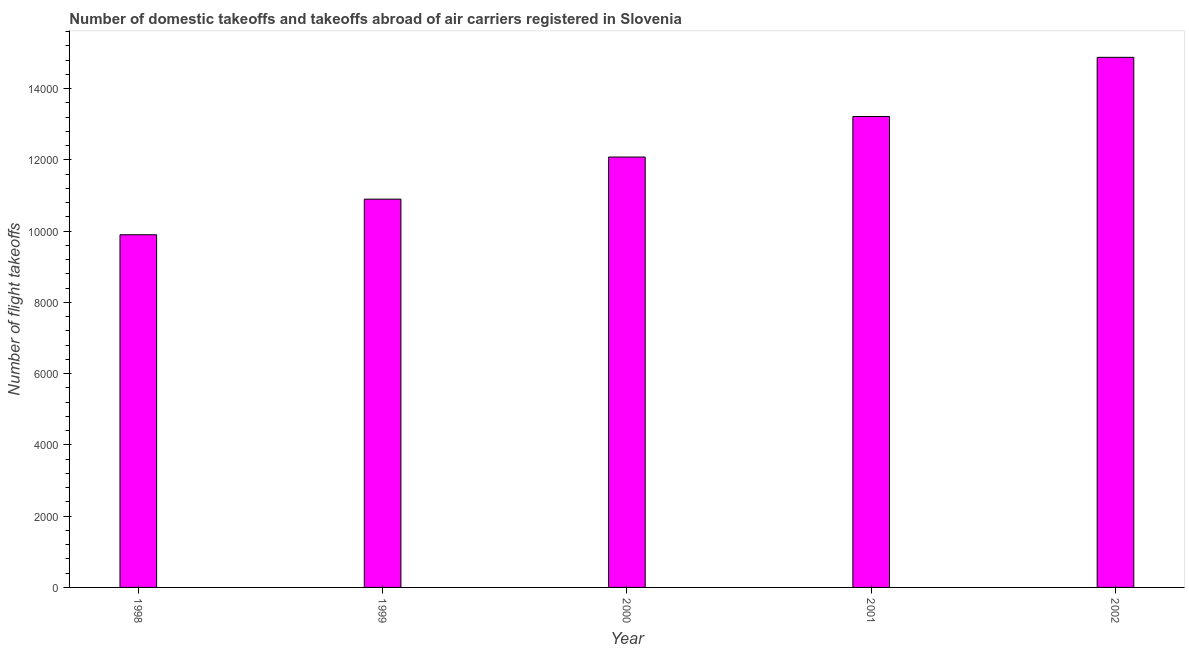Does the graph contain grids?
Provide a short and direct response. No. What is the title of the graph?
Your response must be concise. Number of domestic takeoffs and takeoffs abroad of air carriers registered in Slovenia. What is the label or title of the X-axis?
Offer a very short reply. Year. What is the label or title of the Y-axis?
Your answer should be compact. Number of flight takeoffs. What is the number of flight takeoffs in 2001?
Provide a short and direct response. 1.32e+04. Across all years, what is the maximum number of flight takeoffs?
Make the answer very short. 1.49e+04. Across all years, what is the minimum number of flight takeoffs?
Your answer should be very brief. 9900. What is the sum of the number of flight takeoffs?
Offer a terse response. 6.10e+04. What is the difference between the number of flight takeoffs in 1998 and 1999?
Your response must be concise. -1000. What is the average number of flight takeoffs per year?
Ensure brevity in your answer.  1.22e+04. What is the median number of flight takeoffs?
Provide a succinct answer. 1.21e+04. In how many years, is the number of flight takeoffs greater than 9600 ?
Your response must be concise. 5. What is the ratio of the number of flight takeoffs in 1999 to that in 2002?
Offer a terse response. 0.73. Is the number of flight takeoffs in 1998 less than that in 2002?
Your answer should be very brief. Yes. Is the difference between the number of flight takeoffs in 1999 and 2000 greater than the difference between any two years?
Your response must be concise. No. What is the difference between the highest and the second highest number of flight takeoffs?
Provide a succinct answer. 1661. What is the difference between the highest and the lowest number of flight takeoffs?
Your answer should be compact. 4981. In how many years, is the number of flight takeoffs greater than the average number of flight takeoffs taken over all years?
Provide a short and direct response. 2. Are all the bars in the graph horizontal?
Your answer should be compact. No. How many years are there in the graph?
Ensure brevity in your answer.  5. What is the difference between two consecutive major ticks on the Y-axis?
Offer a very short reply. 2000. What is the Number of flight takeoffs of 1998?
Provide a short and direct response. 9900. What is the Number of flight takeoffs of 1999?
Keep it short and to the point. 1.09e+04. What is the Number of flight takeoffs in 2000?
Offer a very short reply. 1.21e+04. What is the Number of flight takeoffs in 2001?
Make the answer very short. 1.32e+04. What is the Number of flight takeoffs of 2002?
Provide a short and direct response. 1.49e+04. What is the difference between the Number of flight takeoffs in 1998 and 1999?
Provide a short and direct response. -1000. What is the difference between the Number of flight takeoffs in 1998 and 2000?
Offer a very short reply. -2182. What is the difference between the Number of flight takeoffs in 1998 and 2001?
Keep it short and to the point. -3320. What is the difference between the Number of flight takeoffs in 1998 and 2002?
Provide a short and direct response. -4981. What is the difference between the Number of flight takeoffs in 1999 and 2000?
Your answer should be very brief. -1182. What is the difference between the Number of flight takeoffs in 1999 and 2001?
Make the answer very short. -2320. What is the difference between the Number of flight takeoffs in 1999 and 2002?
Provide a short and direct response. -3981. What is the difference between the Number of flight takeoffs in 2000 and 2001?
Make the answer very short. -1138. What is the difference between the Number of flight takeoffs in 2000 and 2002?
Your response must be concise. -2799. What is the difference between the Number of flight takeoffs in 2001 and 2002?
Offer a very short reply. -1661. What is the ratio of the Number of flight takeoffs in 1998 to that in 1999?
Offer a very short reply. 0.91. What is the ratio of the Number of flight takeoffs in 1998 to that in 2000?
Your answer should be compact. 0.82. What is the ratio of the Number of flight takeoffs in 1998 to that in 2001?
Keep it short and to the point. 0.75. What is the ratio of the Number of flight takeoffs in 1998 to that in 2002?
Give a very brief answer. 0.67. What is the ratio of the Number of flight takeoffs in 1999 to that in 2000?
Offer a terse response. 0.9. What is the ratio of the Number of flight takeoffs in 1999 to that in 2001?
Make the answer very short. 0.82. What is the ratio of the Number of flight takeoffs in 1999 to that in 2002?
Your response must be concise. 0.73. What is the ratio of the Number of flight takeoffs in 2000 to that in 2001?
Ensure brevity in your answer.  0.91. What is the ratio of the Number of flight takeoffs in 2000 to that in 2002?
Keep it short and to the point. 0.81. What is the ratio of the Number of flight takeoffs in 2001 to that in 2002?
Your answer should be very brief. 0.89. 